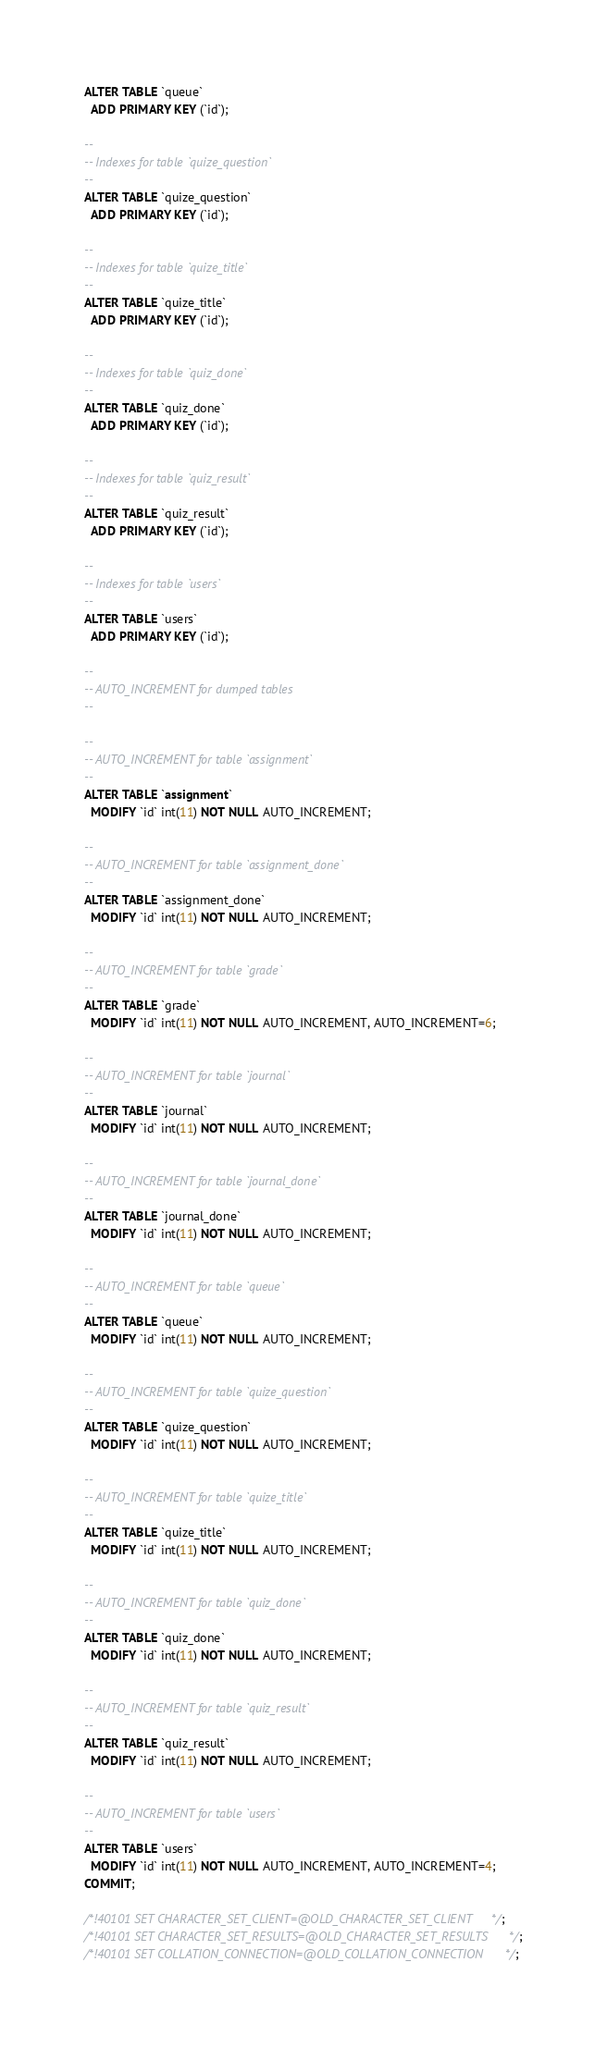<code> <loc_0><loc_0><loc_500><loc_500><_SQL_>ALTER TABLE `queue`
  ADD PRIMARY KEY (`id`);

--
-- Indexes for table `quize_question`
--
ALTER TABLE `quize_question`
  ADD PRIMARY KEY (`id`);

--
-- Indexes for table `quize_title`
--
ALTER TABLE `quize_title`
  ADD PRIMARY KEY (`id`);

--
-- Indexes for table `quiz_done`
--
ALTER TABLE `quiz_done`
  ADD PRIMARY KEY (`id`);

--
-- Indexes for table `quiz_result`
--
ALTER TABLE `quiz_result`
  ADD PRIMARY KEY (`id`);

--
-- Indexes for table `users`
--
ALTER TABLE `users`
  ADD PRIMARY KEY (`id`);

--
-- AUTO_INCREMENT for dumped tables
--

--
-- AUTO_INCREMENT for table `assignment`
--
ALTER TABLE `assignment`
  MODIFY `id` int(11) NOT NULL AUTO_INCREMENT;

--
-- AUTO_INCREMENT for table `assignment_done`
--
ALTER TABLE `assignment_done`
  MODIFY `id` int(11) NOT NULL AUTO_INCREMENT;

--
-- AUTO_INCREMENT for table `grade`
--
ALTER TABLE `grade`
  MODIFY `id` int(11) NOT NULL AUTO_INCREMENT, AUTO_INCREMENT=6;

--
-- AUTO_INCREMENT for table `journal`
--
ALTER TABLE `journal`
  MODIFY `id` int(11) NOT NULL AUTO_INCREMENT;

--
-- AUTO_INCREMENT for table `journal_done`
--
ALTER TABLE `journal_done`
  MODIFY `id` int(11) NOT NULL AUTO_INCREMENT;

--
-- AUTO_INCREMENT for table `queue`
--
ALTER TABLE `queue`
  MODIFY `id` int(11) NOT NULL AUTO_INCREMENT;

--
-- AUTO_INCREMENT for table `quize_question`
--
ALTER TABLE `quize_question`
  MODIFY `id` int(11) NOT NULL AUTO_INCREMENT;

--
-- AUTO_INCREMENT for table `quize_title`
--
ALTER TABLE `quize_title`
  MODIFY `id` int(11) NOT NULL AUTO_INCREMENT;

--
-- AUTO_INCREMENT for table `quiz_done`
--
ALTER TABLE `quiz_done`
  MODIFY `id` int(11) NOT NULL AUTO_INCREMENT;

--
-- AUTO_INCREMENT for table `quiz_result`
--
ALTER TABLE `quiz_result`
  MODIFY `id` int(11) NOT NULL AUTO_INCREMENT;

--
-- AUTO_INCREMENT for table `users`
--
ALTER TABLE `users`
  MODIFY `id` int(11) NOT NULL AUTO_INCREMENT, AUTO_INCREMENT=4;
COMMIT;

/*!40101 SET CHARACTER_SET_CLIENT=@OLD_CHARACTER_SET_CLIENT */;
/*!40101 SET CHARACTER_SET_RESULTS=@OLD_CHARACTER_SET_RESULTS */;
/*!40101 SET COLLATION_CONNECTION=@OLD_COLLATION_CONNECTION */;
</code> 